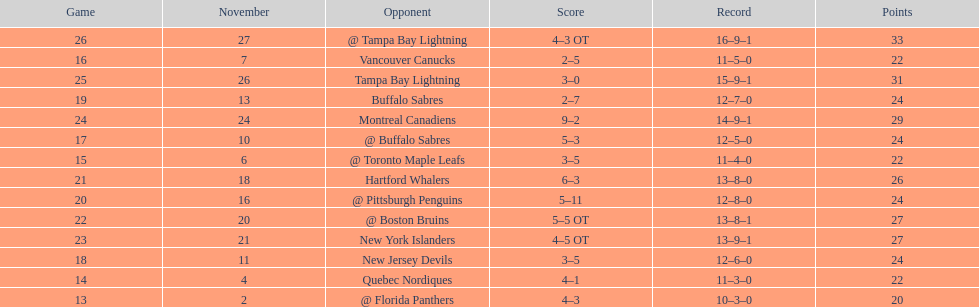What other team had the closest amount of wins? New York Islanders. Write the full table. {'header': ['Game', 'November', 'Opponent', 'Score', 'Record', 'Points'], 'rows': [['26', '27', '@ Tampa Bay Lightning', '4–3 OT', '16–9–1', '33'], ['16', '7', 'Vancouver Canucks', '2–5', '11–5–0', '22'], ['25', '26', 'Tampa Bay Lightning', '3–0', '15–9–1', '31'], ['19', '13', 'Buffalo Sabres', '2–7', '12–7–0', '24'], ['24', '24', 'Montreal Canadiens', '9–2', '14–9–1', '29'], ['17', '10', '@ Buffalo Sabres', '5–3', '12–5–0', '24'], ['15', '6', '@ Toronto Maple Leafs', '3–5', '11–4–0', '22'], ['21', '18', 'Hartford Whalers', '6–3', '13–8–0', '26'], ['20', '16', '@ Pittsburgh Penguins', '5–11', '12–8–0', '24'], ['22', '20', '@ Boston Bruins', '5–5 OT', '13–8–1', '27'], ['23', '21', 'New York Islanders', '4–5 OT', '13–9–1', '27'], ['18', '11', 'New Jersey Devils', '3–5', '12–6–0', '24'], ['14', '4', 'Quebec Nordiques', '4–1', '11–3–0', '22'], ['13', '2', '@ Florida Panthers', '4–3', '10–3–0', '20']]} 